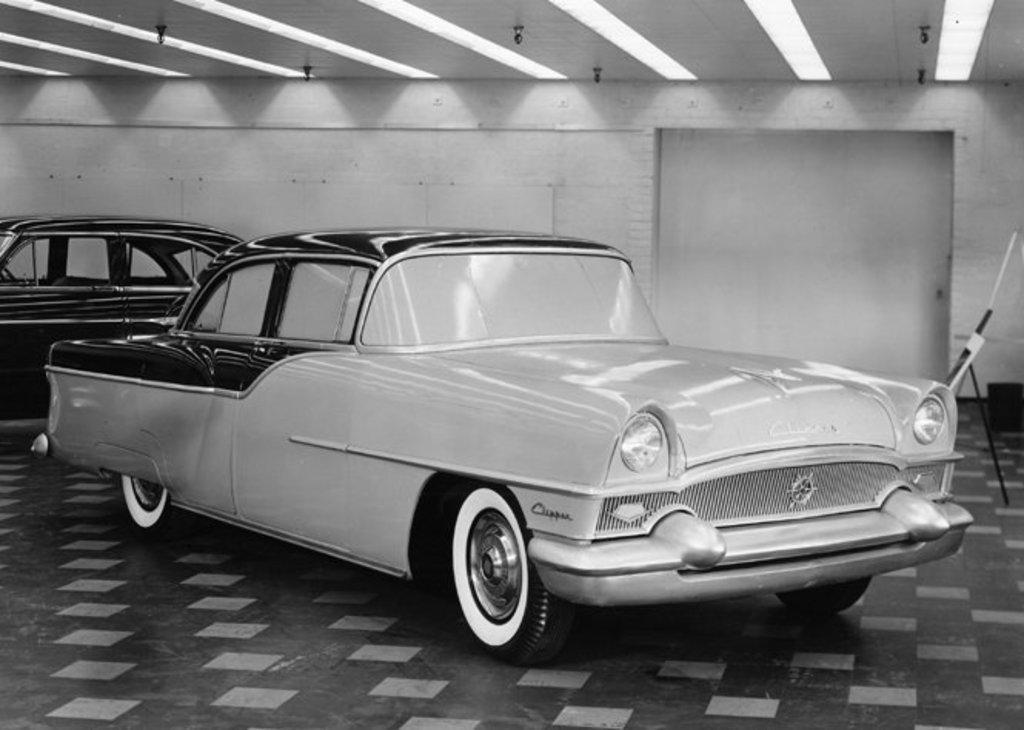How many cars are present in the image? There are two cars in the image. What can be seen in the background of the image? There is a wall in the background of the image. What is the color scheme of the image? The image is black and white. What grade of beef is being served in the image? There is no beef present in the image; it features two cars and a wall in the background. 